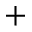Convert formula to latex. <formula><loc_0><loc_0><loc_500><loc_500>+</formula> 